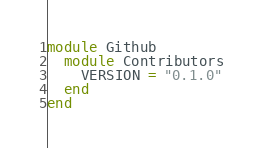Convert code to text. <code><loc_0><loc_0><loc_500><loc_500><_Ruby_>module Github
  module Contributors
    VERSION = "0.1.0"
  end
end
</code> 